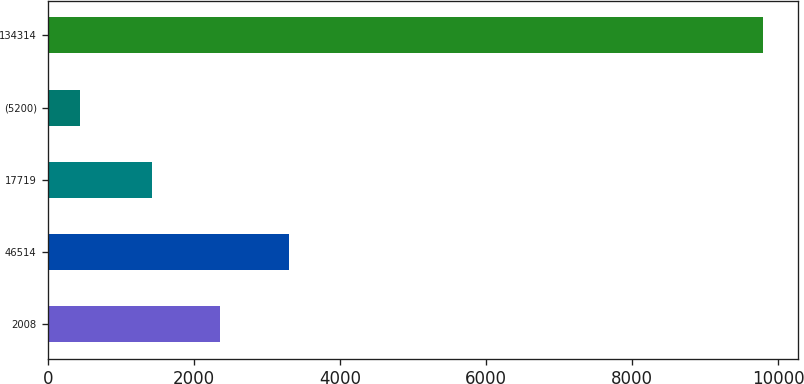Convert chart to OTSL. <chart><loc_0><loc_0><loc_500><loc_500><bar_chart><fcel>2008<fcel>46514<fcel>17719<fcel>(5200)<fcel>134314<nl><fcel>2358.56<fcel>3293.42<fcel>1423.7<fcel>440.4<fcel>9789<nl></chart> 